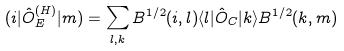Convert formula to latex. <formula><loc_0><loc_0><loc_500><loc_500>( i | { \hat { O } } ^ { ( H ) } _ { E } | m ) = \sum _ { l , k } B ^ { 1 / 2 } ( i , l ) \langle l | { \hat { O } } _ { C } | k \rangle B ^ { 1 / 2 } ( k , m )</formula> 